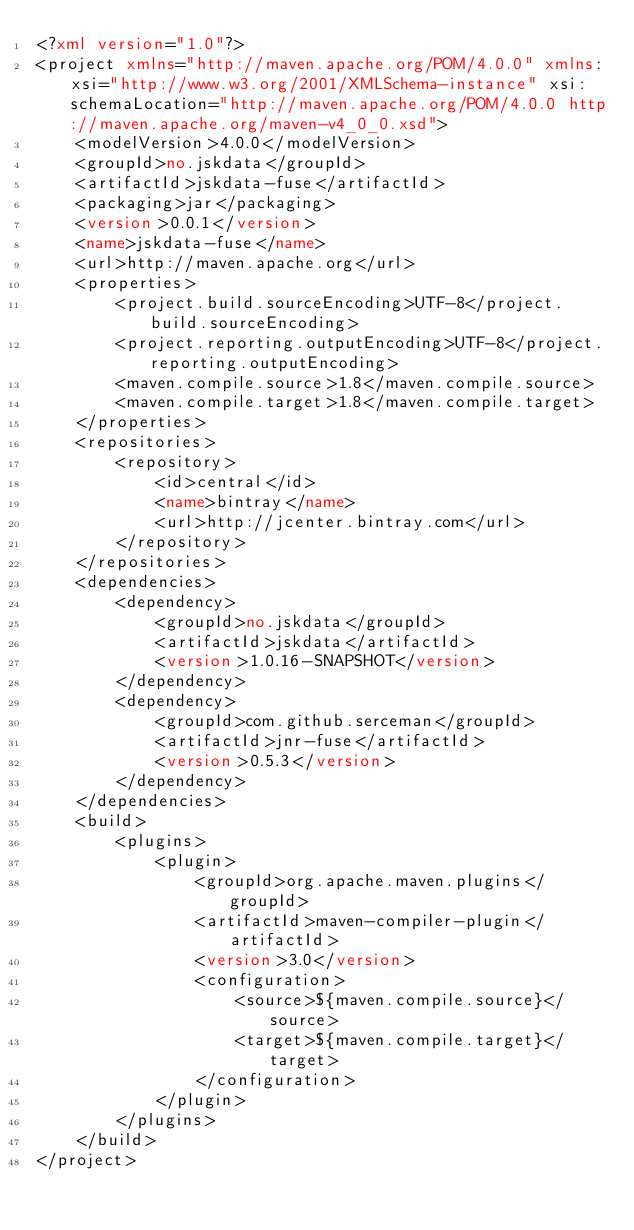Convert code to text. <code><loc_0><loc_0><loc_500><loc_500><_XML_><?xml version="1.0"?>
<project xmlns="http://maven.apache.org/POM/4.0.0" xmlns:xsi="http://www.w3.org/2001/XMLSchema-instance" xsi:schemaLocation="http://maven.apache.org/POM/4.0.0 http://maven.apache.org/maven-v4_0_0.xsd">
    <modelVersion>4.0.0</modelVersion>
    <groupId>no.jskdata</groupId>
    <artifactId>jskdata-fuse</artifactId>
    <packaging>jar</packaging>
    <version>0.0.1</version>
    <name>jskdata-fuse</name>
    <url>http://maven.apache.org</url>
    <properties>
        <project.build.sourceEncoding>UTF-8</project.build.sourceEncoding>
        <project.reporting.outputEncoding>UTF-8</project.reporting.outputEncoding>
        <maven.compile.source>1.8</maven.compile.source>
        <maven.compile.target>1.8</maven.compile.target>
    </properties>
    <repositories>
        <repository>
            <id>central</id>
            <name>bintray</name>
            <url>http://jcenter.bintray.com</url>
        </repository>
    </repositories>
    <dependencies>
        <dependency>
            <groupId>no.jskdata</groupId>
            <artifactId>jskdata</artifactId>
            <version>1.0.16-SNAPSHOT</version>
        </dependency>
        <dependency>
            <groupId>com.github.serceman</groupId>
            <artifactId>jnr-fuse</artifactId>
            <version>0.5.3</version>
        </dependency>
    </dependencies>
    <build>
        <plugins>
            <plugin>
                <groupId>org.apache.maven.plugins</groupId>
                <artifactId>maven-compiler-plugin</artifactId>
                <version>3.0</version>
                <configuration>
                    <source>${maven.compile.source}</source>
                    <target>${maven.compile.target}</target>
                </configuration>
            </plugin>
        </plugins>
    </build>
</project>
</code> 